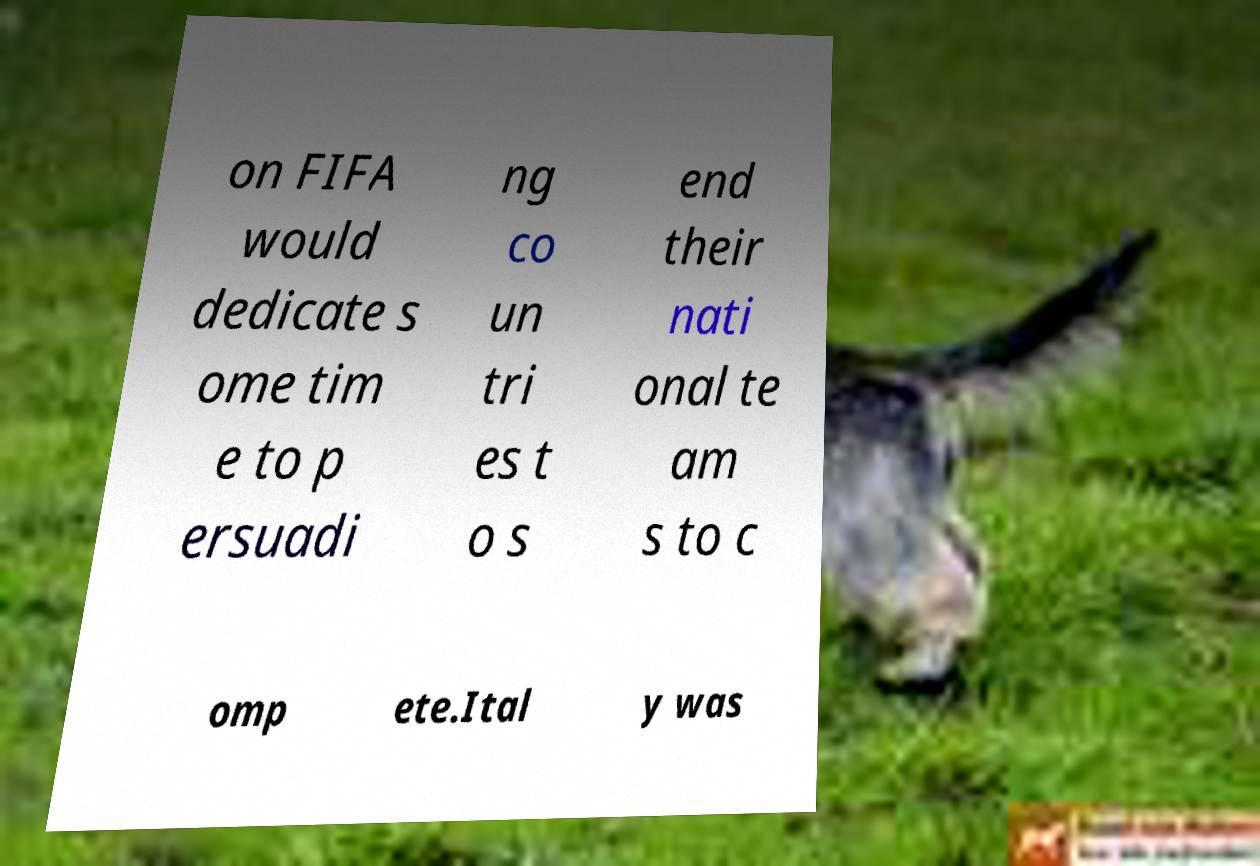For documentation purposes, I need the text within this image transcribed. Could you provide that? on FIFA would dedicate s ome tim e to p ersuadi ng co un tri es t o s end their nati onal te am s to c omp ete.Ital y was 